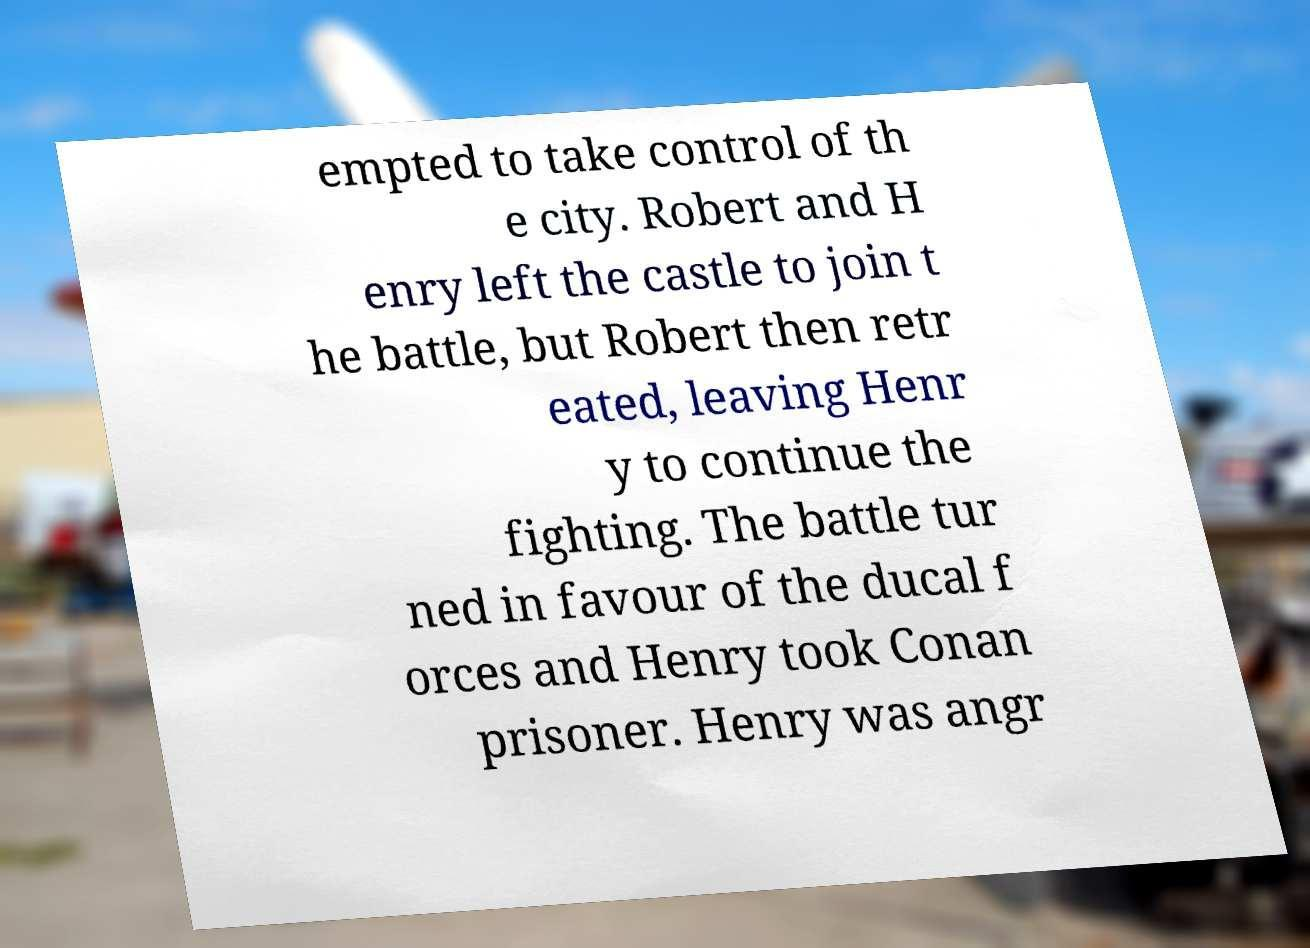Can you accurately transcribe the text from the provided image for me? empted to take control of th e city. Robert and H enry left the castle to join t he battle, but Robert then retr eated, leaving Henr y to continue the fighting. The battle tur ned in favour of the ducal f orces and Henry took Conan prisoner. Henry was angr 